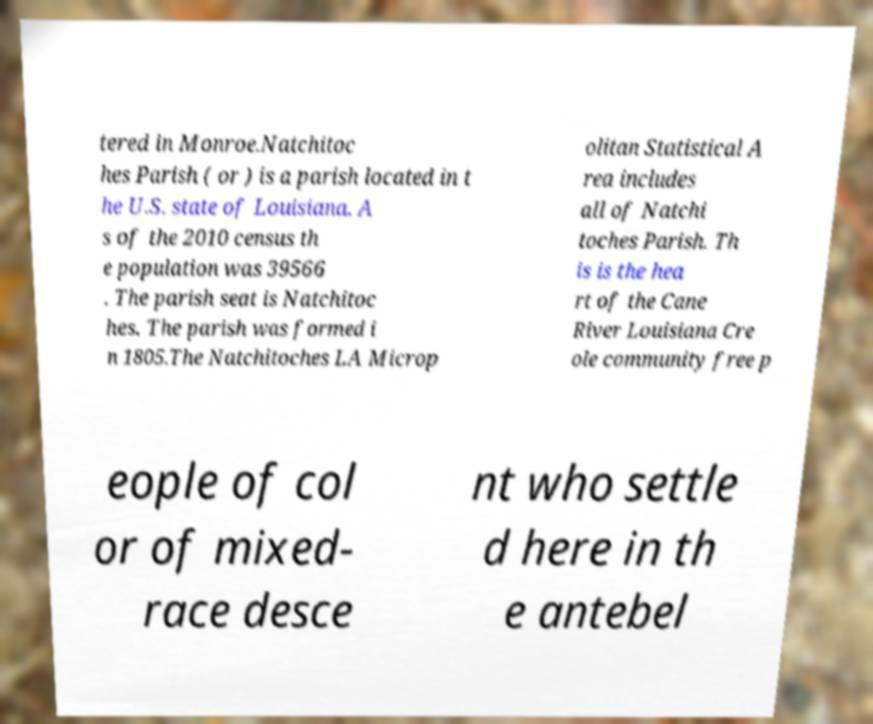Please read and relay the text visible in this image. What does it say? tered in Monroe.Natchitoc hes Parish ( or ) is a parish located in t he U.S. state of Louisiana. A s of the 2010 census th e population was 39566 . The parish seat is Natchitoc hes. The parish was formed i n 1805.The Natchitoches LA Microp olitan Statistical A rea includes all of Natchi toches Parish. Th is is the hea rt of the Cane River Louisiana Cre ole community free p eople of col or of mixed- race desce nt who settle d here in th e antebel 